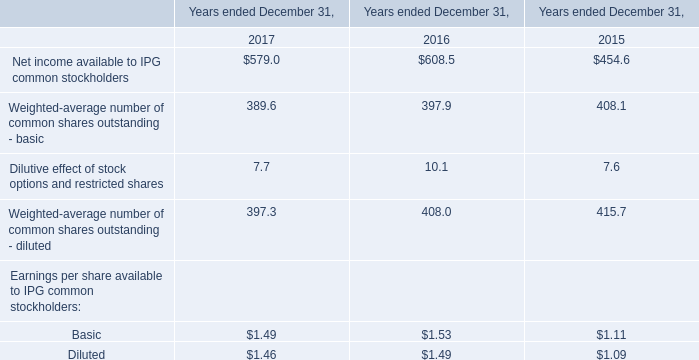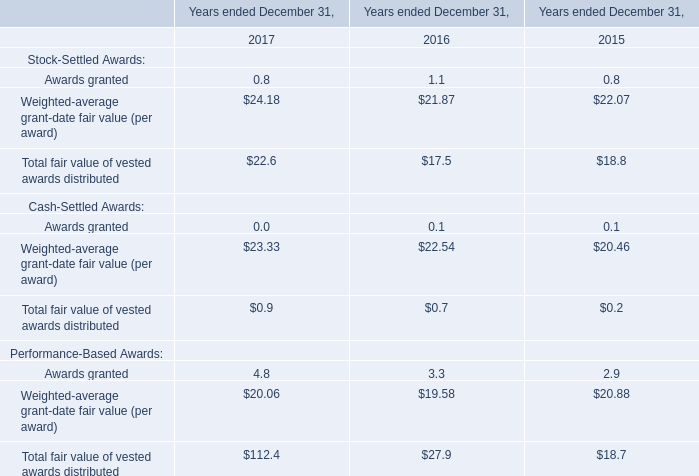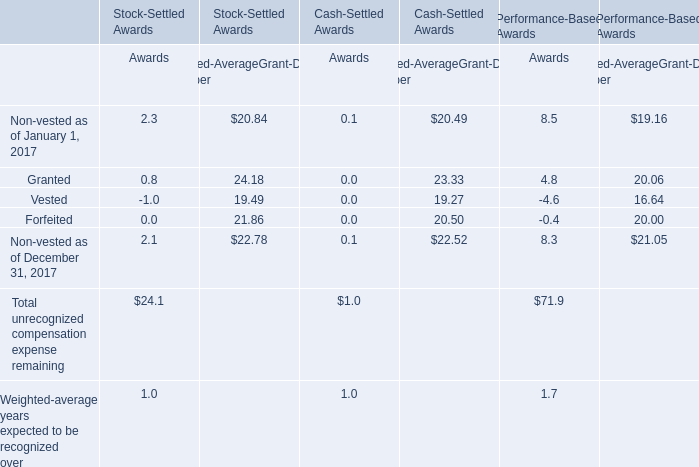In which section the sum of Total unrecognized compensation expense remaining has the highest value? 
Answer: Awards of Performance-Based Awards. How many Stock-Settled Awards exceed the average of Stock-Settled Awards in 2017? 
Answer: 2. What do all Stock-Settled Awards sum up, excluding those negative ones in 2017? 
Computations: ((0.8 + 24.18) + 22.6)
Answer: 47.58. 